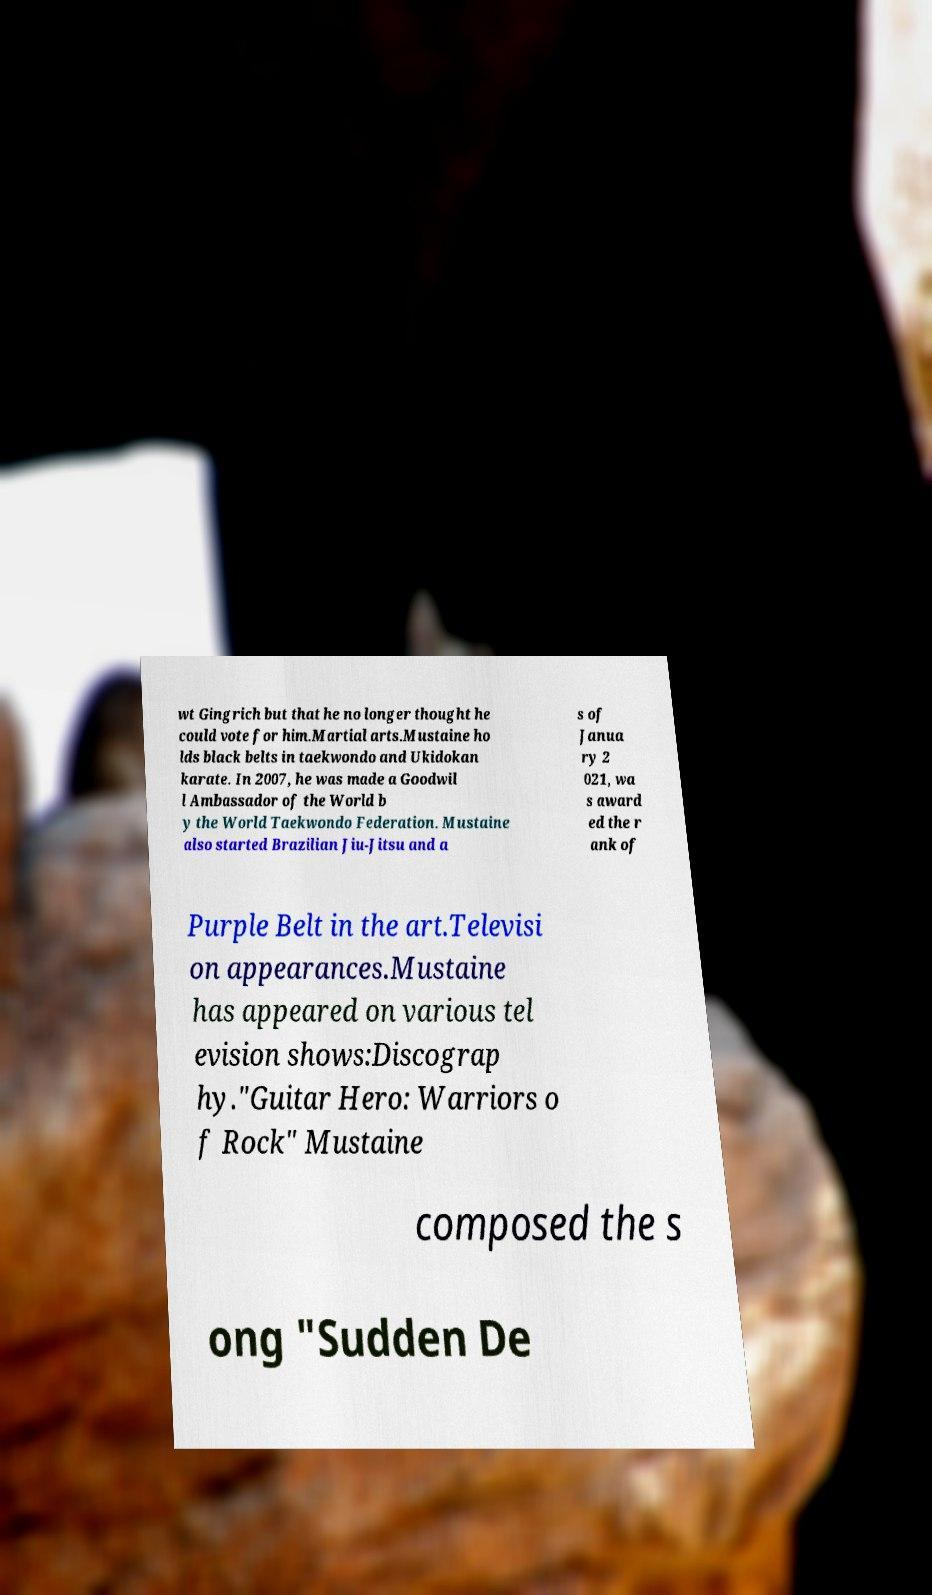Please read and relay the text visible in this image. What does it say? wt Gingrich but that he no longer thought he could vote for him.Martial arts.Mustaine ho lds black belts in taekwondo and Ukidokan karate. In 2007, he was made a Goodwil l Ambassador of the World b y the World Taekwondo Federation. Mustaine also started Brazilian Jiu-Jitsu and a s of Janua ry 2 021, wa s award ed the r ank of Purple Belt in the art.Televisi on appearances.Mustaine has appeared on various tel evision shows:Discograp hy."Guitar Hero: Warriors o f Rock" Mustaine composed the s ong "Sudden De 